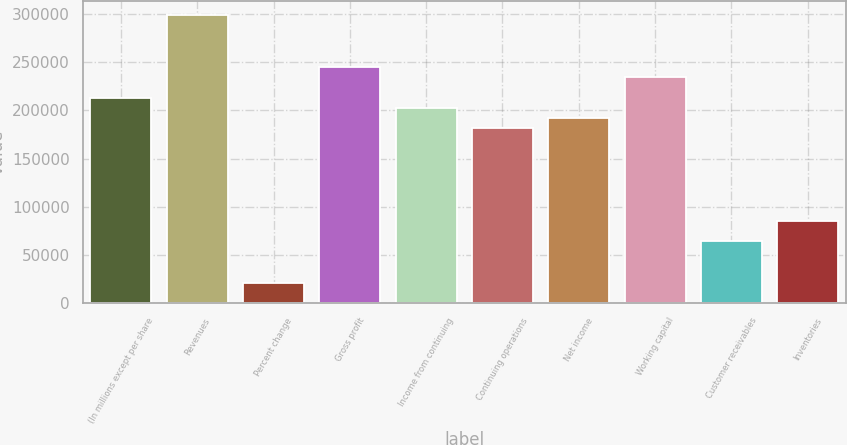Convert chart. <chart><loc_0><loc_0><loc_500><loc_500><bar_chart><fcel>(In millions except per share<fcel>Revenues<fcel>Percent change<fcel>Gross profit<fcel>Income from continuing<fcel>Continuing operations<fcel>Net income<fcel>Working capital<fcel>Customer receivables<fcel>Inventories<nl><fcel>213263<fcel>298569<fcel>21326.8<fcel>245253<fcel>202600<fcel>181274<fcel>191937<fcel>234590<fcel>63979.4<fcel>85305.7<nl></chart> 